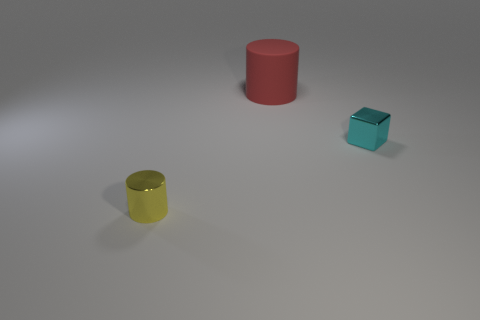Add 3 matte cylinders. How many objects exist? 6 Subtract all cylinders. How many objects are left? 1 Add 3 red metal spheres. How many red metal spheres exist? 3 Subtract 1 cyan cubes. How many objects are left? 2 Subtract all small brown metal cylinders. Subtract all tiny yellow cylinders. How many objects are left? 2 Add 1 tiny objects. How many tiny objects are left? 3 